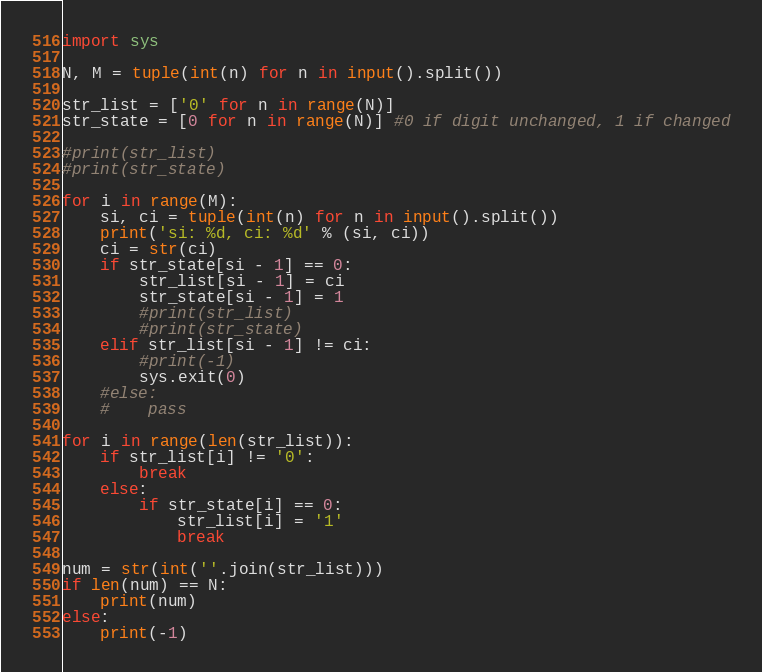<code> <loc_0><loc_0><loc_500><loc_500><_Python_>import sys

N, M = tuple(int(n) for n in input().split())

str_list = ['0' for n in range(N)]
str_state = [0 for n in range(N)] #0 if digit unchanged, 1 if changed

#print(str_list)
#print(str_state)

for i in range(M):
    si, ci = tuple(int(n) for n in input().split())
    print('si: %d, ci: %d' % (si, ci))
    ci = str(ci)
    if str_state[si - 1] == 0:
        str_list[si - 1] = ci
        str_state[si - 1] = 1
        #print(str_list)
        #print(str_state)
    elif str_list[si - 1] != ci:
        #print(-1)
        sys.exit(0)
    #else:
    #    pass

for i in range(len(str_list)):
    if str_list[i] != '0':
        break
    else:
        if str_state[i] == 0:
            str_list[i] = '1'
            break

num = str(int(''.join(str_list)))
if len(num) == N:
    print(num)
else:
    print(-1)
</code> 